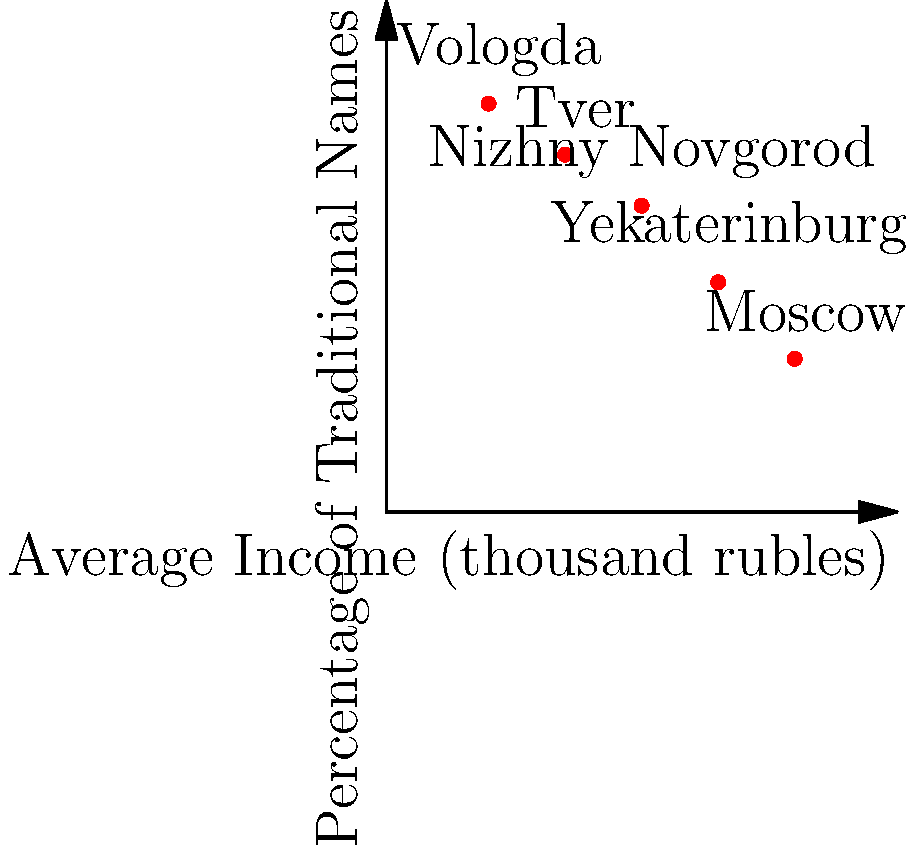Based on the scatter plot showing the relationship between average income and the percentage of traditional names in various Russian regions, what trend can be observed in naming patterns as socioeconomic status increases? To answer this question, we need to analyze the trend shown in the scatter plot:

1. Identify the variables:
   - X-axis: Average Income (thousand rubles)
   - Y-axis: Percentage of Traditional Names

2. Observe the data points:
   - Vologda: Low income, high percentage of traditional names
   - Tver: Lower-middle income, high-middle percentage of traditional names
   - Nizhny Novgorod: Middle income, middle percentage of traditional names
   - Yekaterinburg: Upper-middle income, lower-middle percentage of traditional names
   - Moscow: High income, low percentage of traditional names

3. Analyze the trend:
   - As we move from left to right (increasing average income), we see a decrease in the percentage of traditional names.
   - This indicates a negative correlation between socioeconomic status and the use of traditional names.

4. Interpret the trend:
   - Regions with higher average incomes (e.g., Moscow) tend to have a lower percentage of traditional names.
   - Regions with lower average incomes (e.g., Vologda) tend to have a higher percentage of traditional names.

5. Conclusion:
   The trend shows that as socioeconomic status increases, there is a decrease in the use of traditional names, suggesting that higher-income regions are more likely to adopt non-traditional or modern naming patterns.
Answer: Decrease in traditional names as income increases 